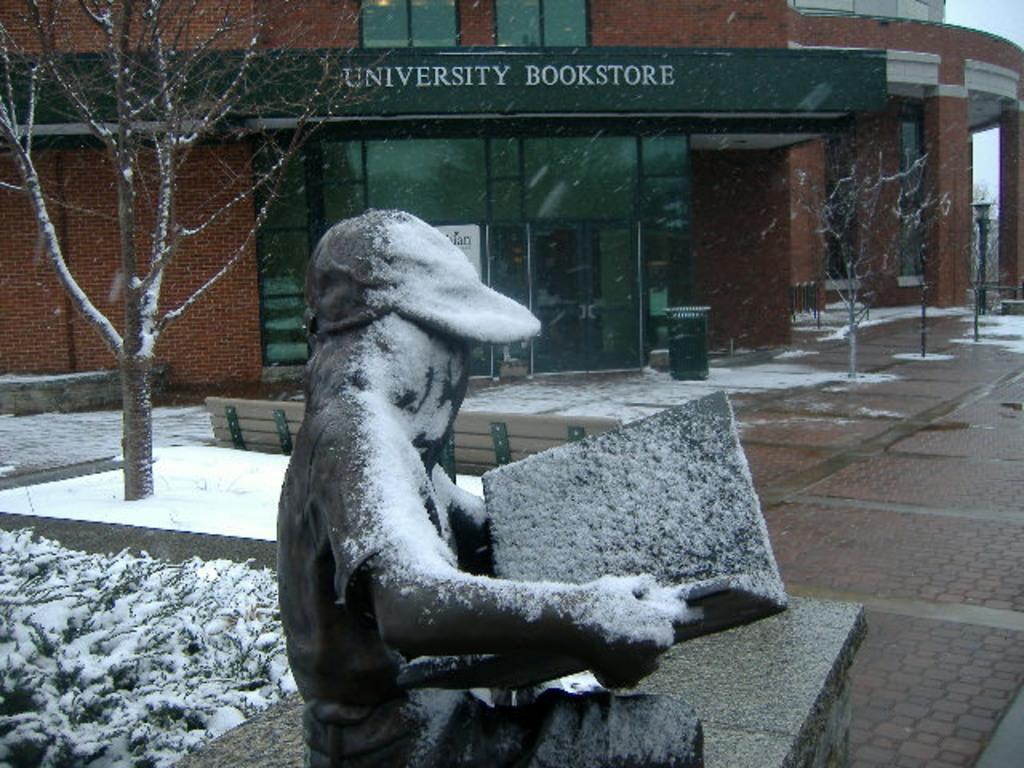Could you give a brief overview of what you see in this image? In this picture I can see a statue in front, which is holding a thing and I see the statue on the bench. In the middle of this picture I can see the plants and trees on which there is snow and I see the path. In the background I can see a building on which there is a something written. I can also see a bench in the center of this picture. 